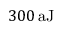Convert formula to latex. <formula><loc_0><loc_0><loc_500><loc_500>{ 3 0 0 } \, a J</formula> 